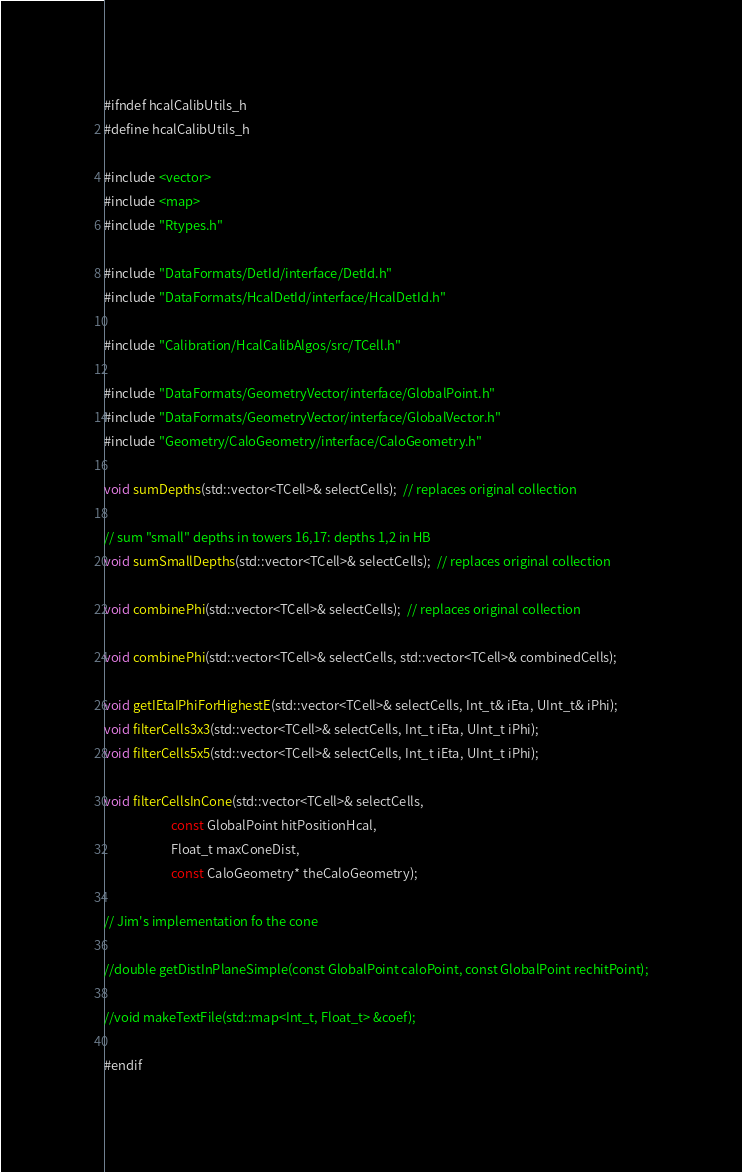Convert code to text. <code><loc_0><loc_0><loc_500><loc_500><_C_>#ifndef hcalCalibUtils_h
#define hcalCalibUtils_h

#include <vector>
#include <map>
#include "Rtypes.h"

#include "DataFormats/DetId/interface/DetId.h"
#include "DataFormats/HcalDetId/interface/HcalDetId.h"

#include "Calibration/HcalCalibAlgos/src/TCell.h"

#include "DataFormats/GeometryVector/interface/GlobalPoint.h"
#include "DataFormats/GeometryVector/interface/GlobalVector.h"
#include "Geometry/CaloGeometry/interface/CaloGeometry.h"

void sumDepths(std::vector<TCell>& selectCells);  // replaces original collection

// sum "small" depths in towers 16,17: depths 1,2 in HB
void sumSmallDepths(std::vector<TCell>& selectCells);  // replaces original collection

void combinePhi(std::vector<TCell>& selectCells);  // replaces original collection

void combinePhi(std::vector<TCell>& selectCells, std::vector<TCell>& combinedCells);

void getIEtaIPhiForHighestE(std::vector<TCell>& selectCells, Int_t& iEta, UInt_t& iPhi);
void filterCells3x3(std::vector<TCell>& selectCells, Int_t iEta, UInt_t iPhi);
void filterCells5x5(std::vector<TCell>& selectCells, Int_t iEta, UInt_t iPhi);

void filterCellsInCone(std::vector<TCell>& selectCells,
                       const GlobalPoint hitPositionHcal,
                       Float_t maxConeDist,
                       const CaloGeometry* theCaloGeometry);

// Jim's implementation fo the cone

//double getDistInPlaneSimple(const GlobalPoint caloPoint, const GlobalPoint rechitPoint);

//void makeTextFile(std::map<Int_t, Float_t> &coef);

#endif
</code> 